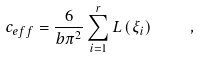Convert formula to latex. <formula><loc_0><loc_0><loc_500><loc_500>c _ { e f f } = \frac { 6 } { b \pi ^ { 2 } } \sum _ { i = 1 } ^ { r } L \left ( \xi _ { i } \right ) \quad ,</formula> 